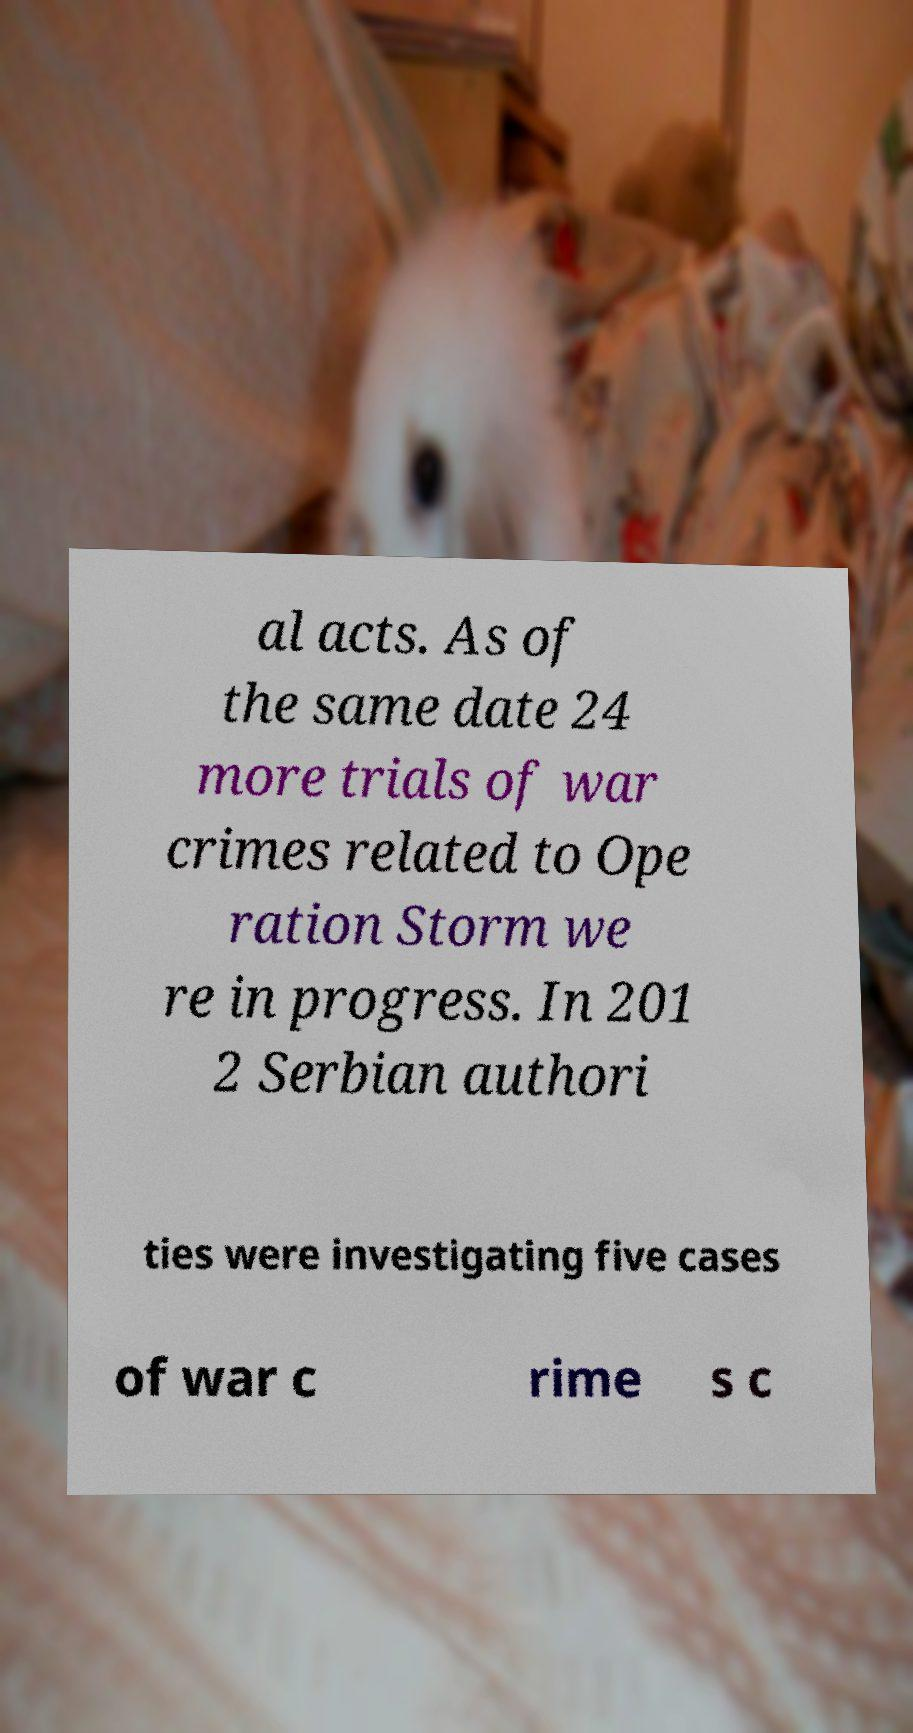What messages or text are displayed in this image? I need them in a readable, typed format. al acts. As of the same date 24 more trials of war crimes related to Ope ration Storm we re in progress. In 201 2 Serbian authori ties were investigating five cases of war c rime s c 